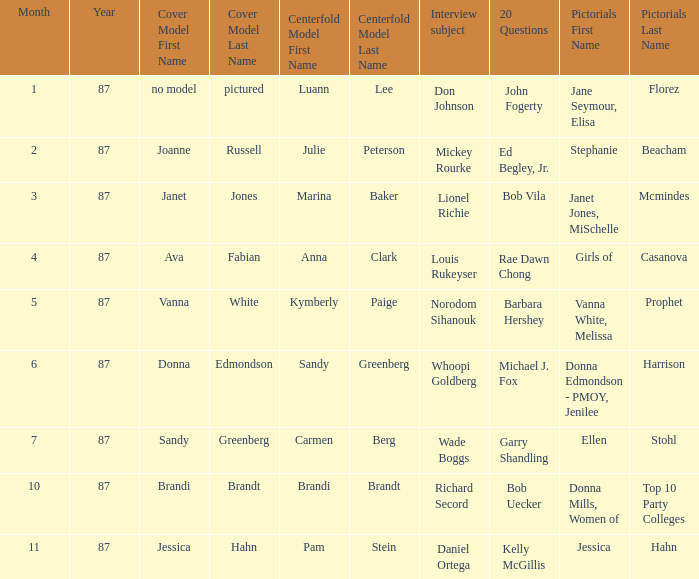Who was the on the cover when Bob Vila did the 20 Questions? Janet Jones. 